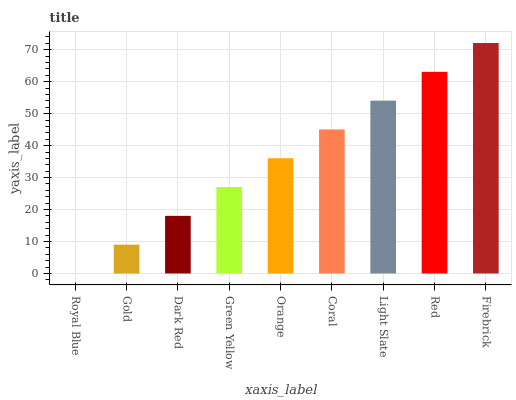Is Royal Blue the minimum?
Answer yes or no. Yes. Is Firebrick the maximum?
Answer yes or no. Yes. Is Gold the minimum?
Answer yes or no. No. Is Gold the maximum?
Answer yes or no. No. Is Gold greater than Royal Blue?
Answer yes or no. Yes. Is Royal Blue less than Gold?
Answer yes or no. Yes. Is Royal Blue greater than Gold?
Answer yes or no. No. Is Gold less than Royal Blue?
Answer yes or no. No. Is Orange the high median?
Answer yes or no. Yes. Is Orange the low median?
Answer yes or no. Yes. Is Firebrick the high median?
Answer yes or no. No. Is Royal Blue the low median?
Answer yes or no. No. 